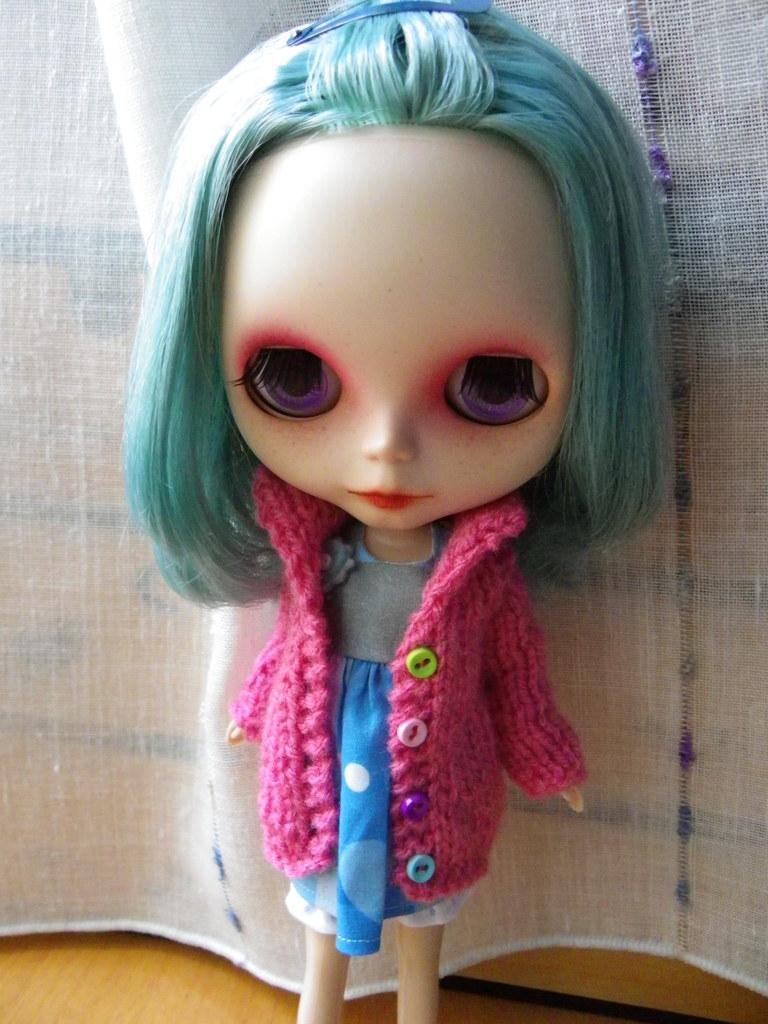What is the main subject in the image? There is a doll in the image. What type of surface is at the bottom of the image? There is a wooden surface at the bottom of the image. What is placed on the wooden surface? There is an object on the wooden surface. What can be seen behind the doll in the image? There is a curtain behind the doll. How does the doll adjust its comfort level in the image? The doll does not have the ability to adjust its comfort level, as it is an inanimate object. 